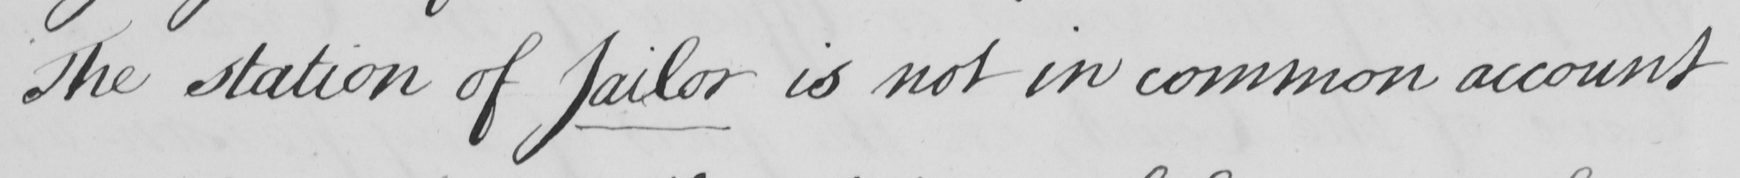Please provide the text content of this handwritten line. The station of Jailor is not in common account 